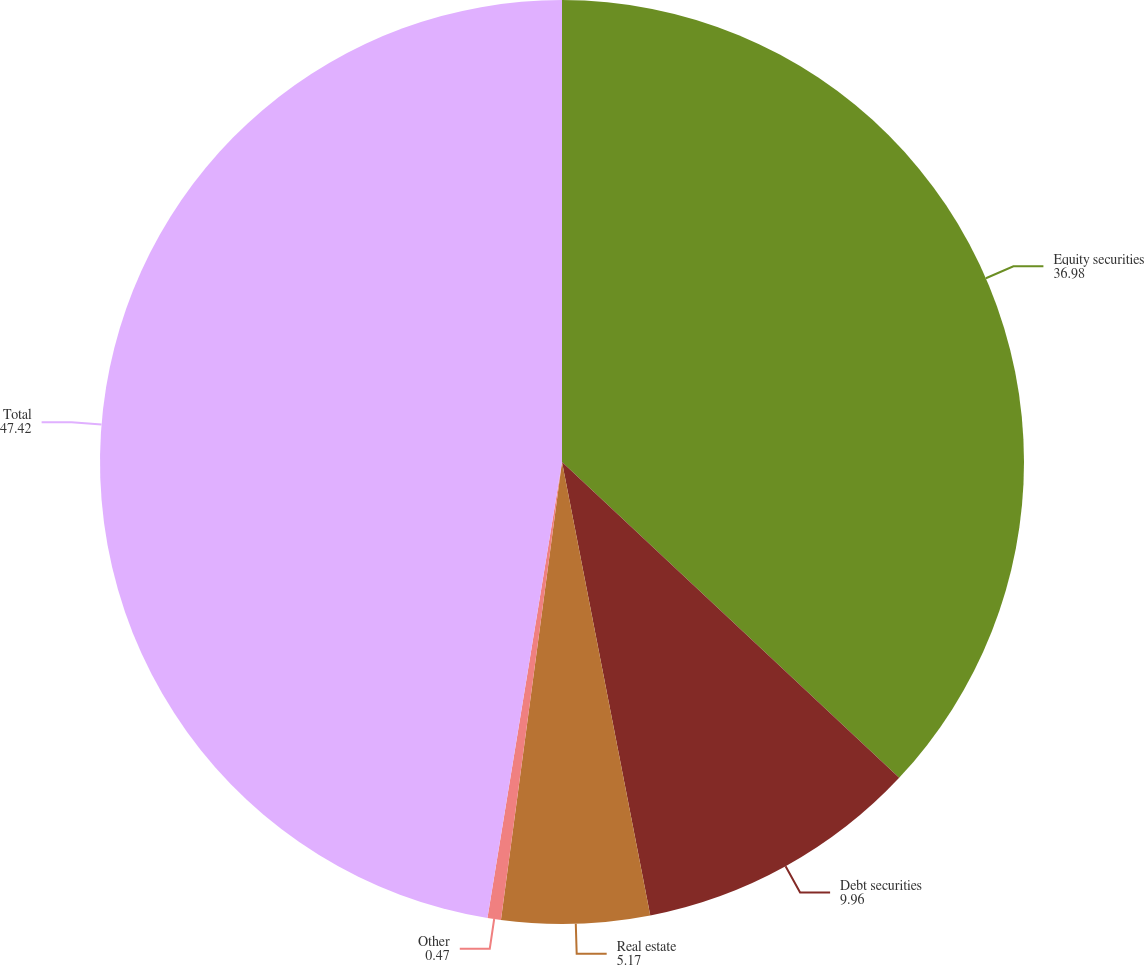Convert chart. <chart><loc_0><loc_0><loc_500><loc_500><pie_chart><fcel>Equity securities<fcel>Debt securities<fcel>Real estate<fcel>Other<fcel>Total<nl><fcel>36.98%<fcel>9.96%<fcel>5.17%<fcel>0.47%<fcel>47.42%<nl></chart> 